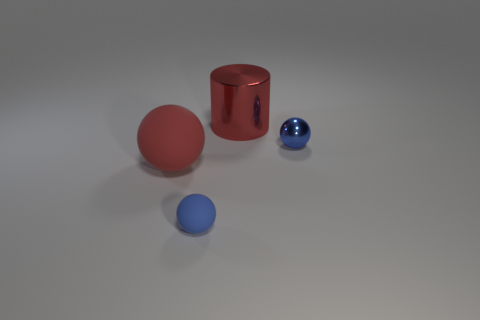Does the image suggest any particular use for the objects? The objects are simple geometric shapes often used in visualizations to demonstrate shading, lighting, and perspective. They don't indicate a specific practical use but are typically used for display and instruction in 3D modeling and rendering. 